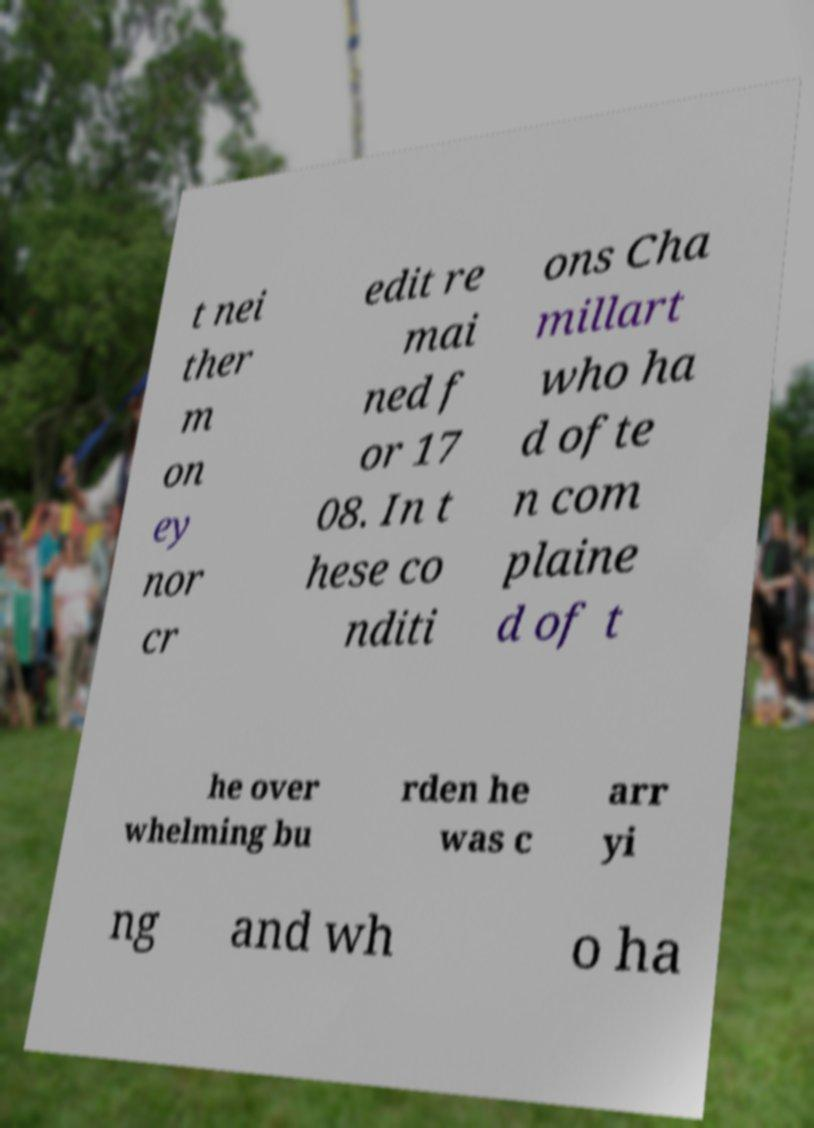What messages or text are displayed in this image? I need them in a readable, typed format. t nei ther m on ey nor cr edit re mai ned f or 17 08. In t hese co nditi ons Cha millart who ha d ofte n com plaine d of t he over whelming bu rden he was c arr yi ng and wh o ha 